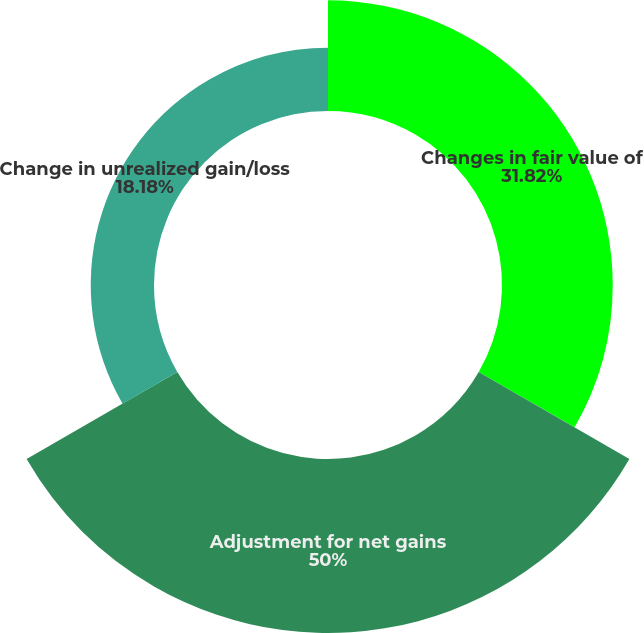Convert chart to OTSL. <chart><loc_0><loc_0><loc_500><loc_500><pie_chart><fcel>Changes in fair value of<fcel>Adjustment for net gains<fcel>Change in unrealized gain/loss<nl><fcel>31.82%<fcel>50.0%<fcel>18.18%<nl></chart> 